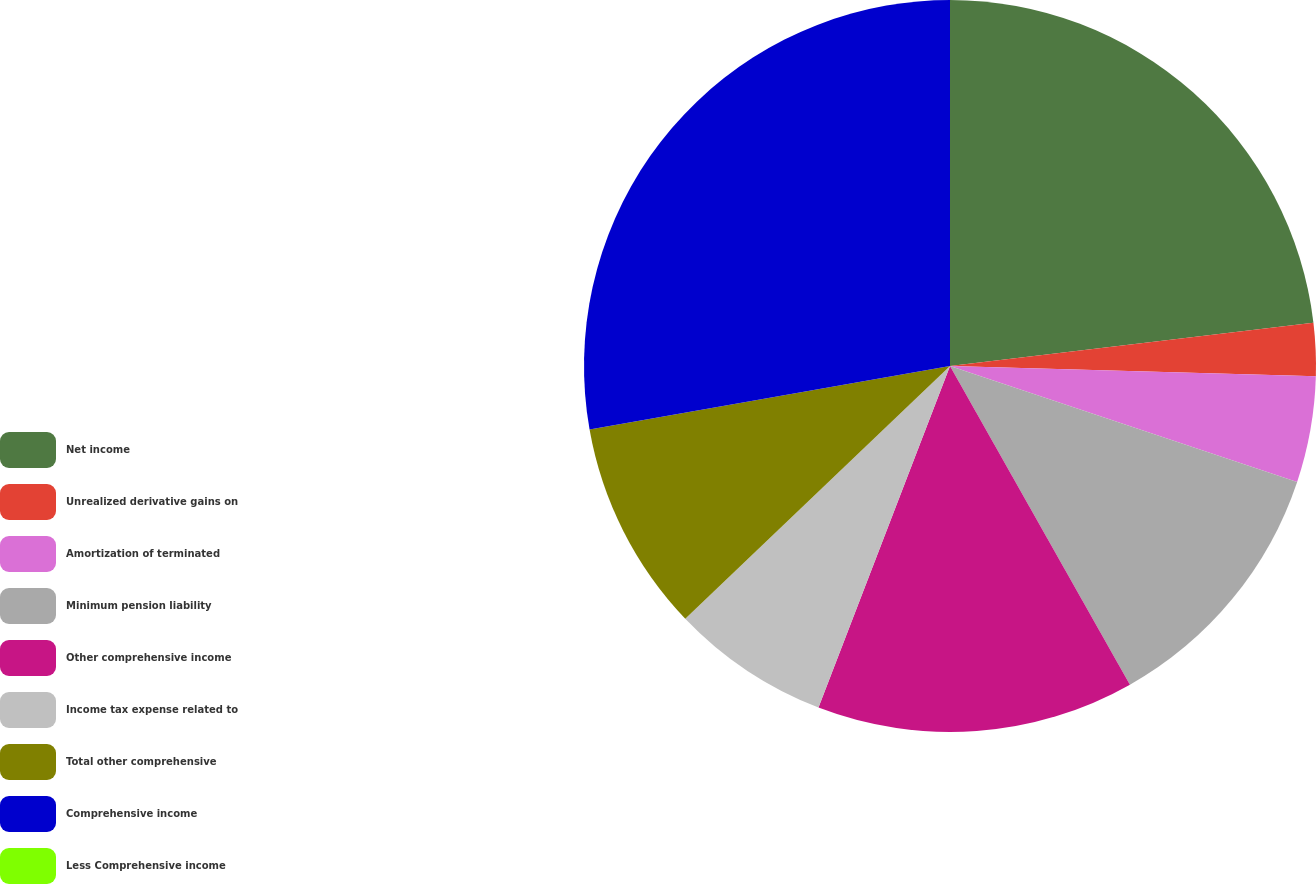Convert chart to OTSL. <chart><loc_0><loc_0><loc_500><loc_500><pie_chart><fcel>Net income<fcel>Unrealized derivative gains on<fcel>Amortization of terminated<fcel>Minimum pension liability<fcel>Other comprehensive income<fcel>Income tax expense related to<fcel>Total other comprehensive<fcel>Comprehensive income<fcel>Less Comprehensive income<nl><fcel>23.11%<fcel>2.34%<fcel>4.68%<fcel>11.69%<fcel>14.03%<fcel>7.02%<fcel>9.35%<fcel>27.78%<fcel>0.0%<nl></chart> 